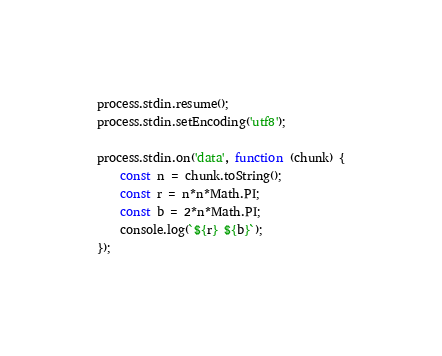<code> <loc_0><loc_0><loc_500><loc_500><_JavaScript_>
process.stdin.resume();
process.stdin.setEncoding('utf8');

process.stdin.on('data', function (chunk) {
    const n = chunk.toString();
    const r = n*n*Math.PI;
    const b = 2*n*Math.PI;
    console.log(`${r} ${b}`);
});
</code> 